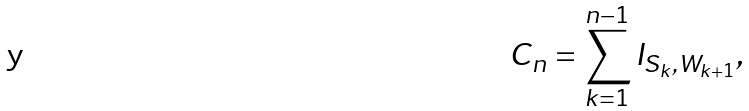Convert formula to latex. <formula><loc_0><loc_0><loc_500><loc_500>C _ { n } = \sum _ { k = 1 } ^ { n - 1 } I _ { S _ { k } , W _ { k + 1 } } ,</formula> 